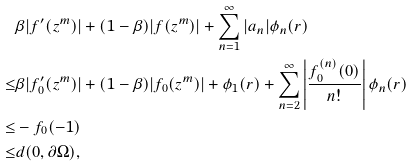<formula> <loc_0><loc_0><loc_500><loc_500>& \beta | f ^ { \prime } ( z ^ { m } ) | + ( 1 - \beta ) | f ( z ^ { m } ) | + \sum _ { n = 1 } ^ { \infty } | a _ { n } | \phi _ { n } ( r ) \\ \leq & \beta | f ^ { \prime } _ { 0 } ( z ^ { m } ) | + ( 1 - \beta ) | f _ { 0 } ( z ^ { m } ) | + \phi _ { 1 } ( r ) + \sum _ { n = 2 } ^ { \infty } \left | \frac { f ^ { ( n ) } _ { 0 } ( 0 ) } { n ! } \right | \phi _ { n } ( r ) \\ \leq & - f _ { 0 } ( - 1 ) \\ \leq & d ( 0 , \partial { \Omega } ) ,</formula> 